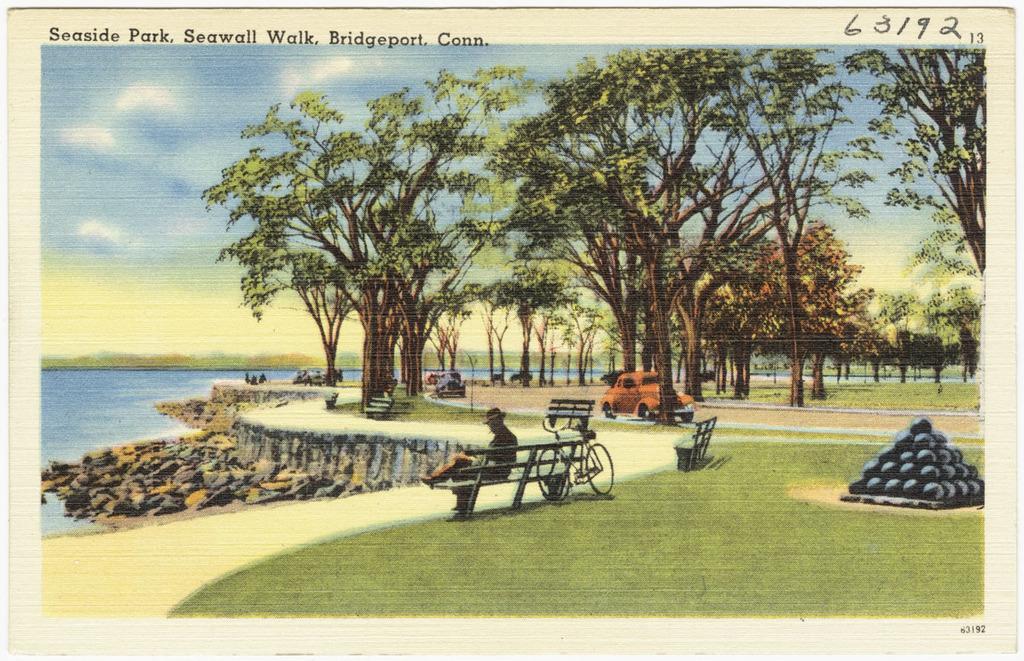Can you describe this image briefly? This is a painting. On the left side there is water, rocks and a road. Near to the road there are benches. And a person wearing hat is sitting on the bench. Near to that there is a cycle. On the ground there is grass. There is a road. On the road there are vehicles. In the back there are trees. Also there are round objects on the right side. In the background there is sky. At the top something is written on the image. 